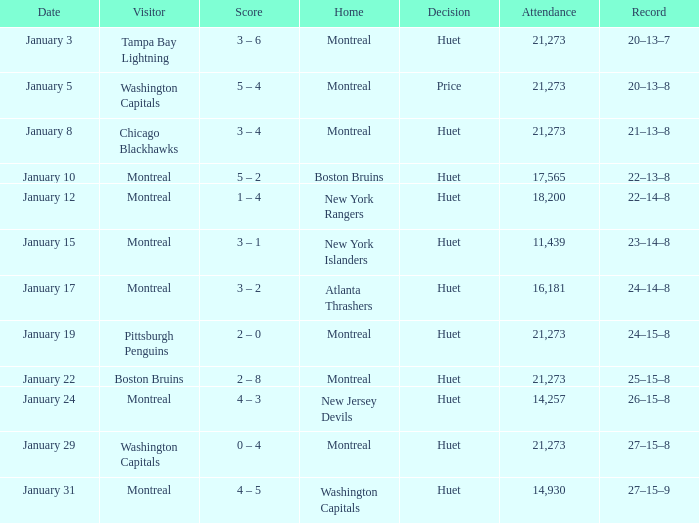What was the outcome of the match when the boston bruins were the away team? 2 – 8. 